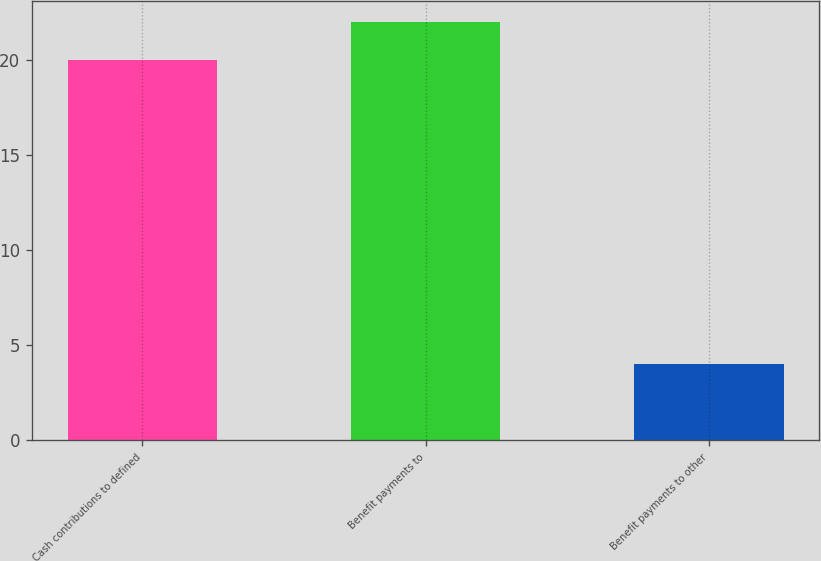Convert chart. <chart><loc_0><loc_0><loc_500><loc_500><bar_chart><fcel>Cash contributions to defined<fcel>Benefit payments to<fcel>Benefit payments to other<nl><fcel>20<fcel>22<fcel>4<nl></chart> 